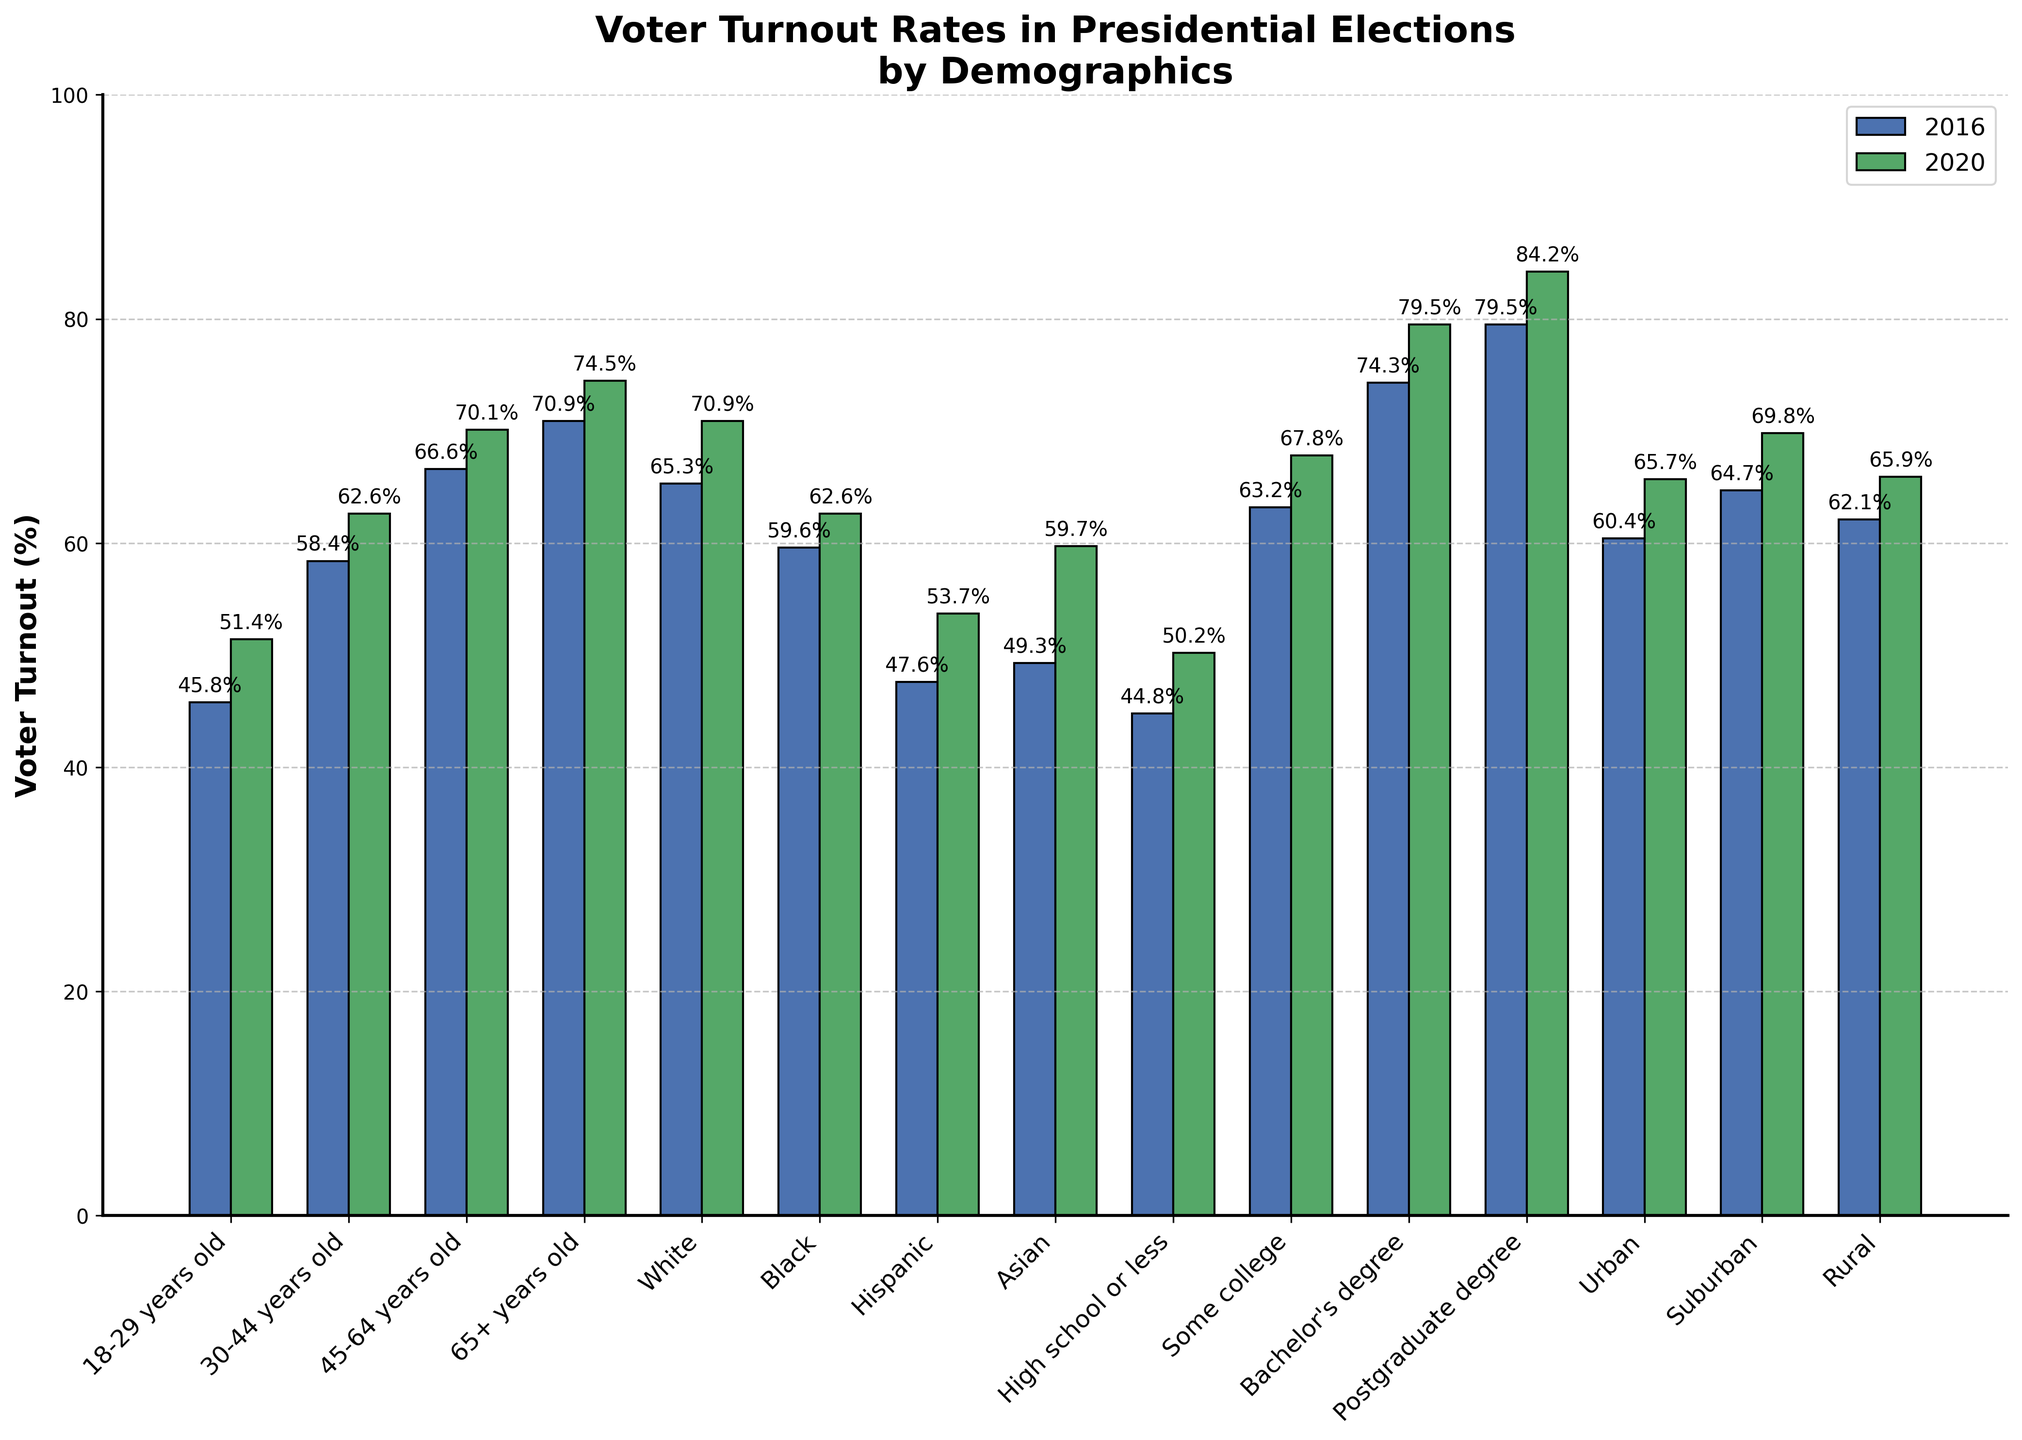What was the voter turnout rate for the 30-44 years old demographic in 2016 and 2020? Check the lengths of the bars labeled "30-44 years old" for both years. The bar representing 2016 is at 58.4% and the bar for 2020 is at 62.6%.
Answer: 58.4% in 2016, 62.6% in 2020 Which demographic had the highest voter turnout rate in 2020? Compare the height of all the bars representing 2020 turnout rates. The highest bar corresponds to the demographic with a postgraduate degree at 84.2%.
Answer: Postgraduate degree By how many percentage points did the voter turnout rate increase for the Hispanic demographic from 2016 to 2020? Subtract the height of the bar for 2016 from the bar for 2020 in the Hispanic category: 53.7% - 47.6% equals 6.1 percentage points.
Answer: 6.1 percentage points Which demographic had the smallest increase in voter turnout rate from 2016 to 2020? Calculate the difference in height between bars for each demographic and identify the smallest change. The smallest increase is for the Black demographic, from 59.6% to 62.6% (3 percentage points).
Answer: Black What is the difference in voter turnout rate between the "Urban" and "Rural" demographics in 2020? Subtract the height of the "Rural" bar from the "Urban" bar for 2020: 65.7% - 65.9% equals -0.2 percentage points, meaning rural turnout is slightly higher.
Answer: -0.2 percentage points Which age group had the most significant increase in voter turnout rate between 2016 and 2020? Calculate the difference in height between the bars for 2016 and 2020 for each age group and identify the largest change. The 18-29 years old group had the most significant increase from 45.8% to 51.4% (5.6 percentage points).
Answer: 18-29 years old 